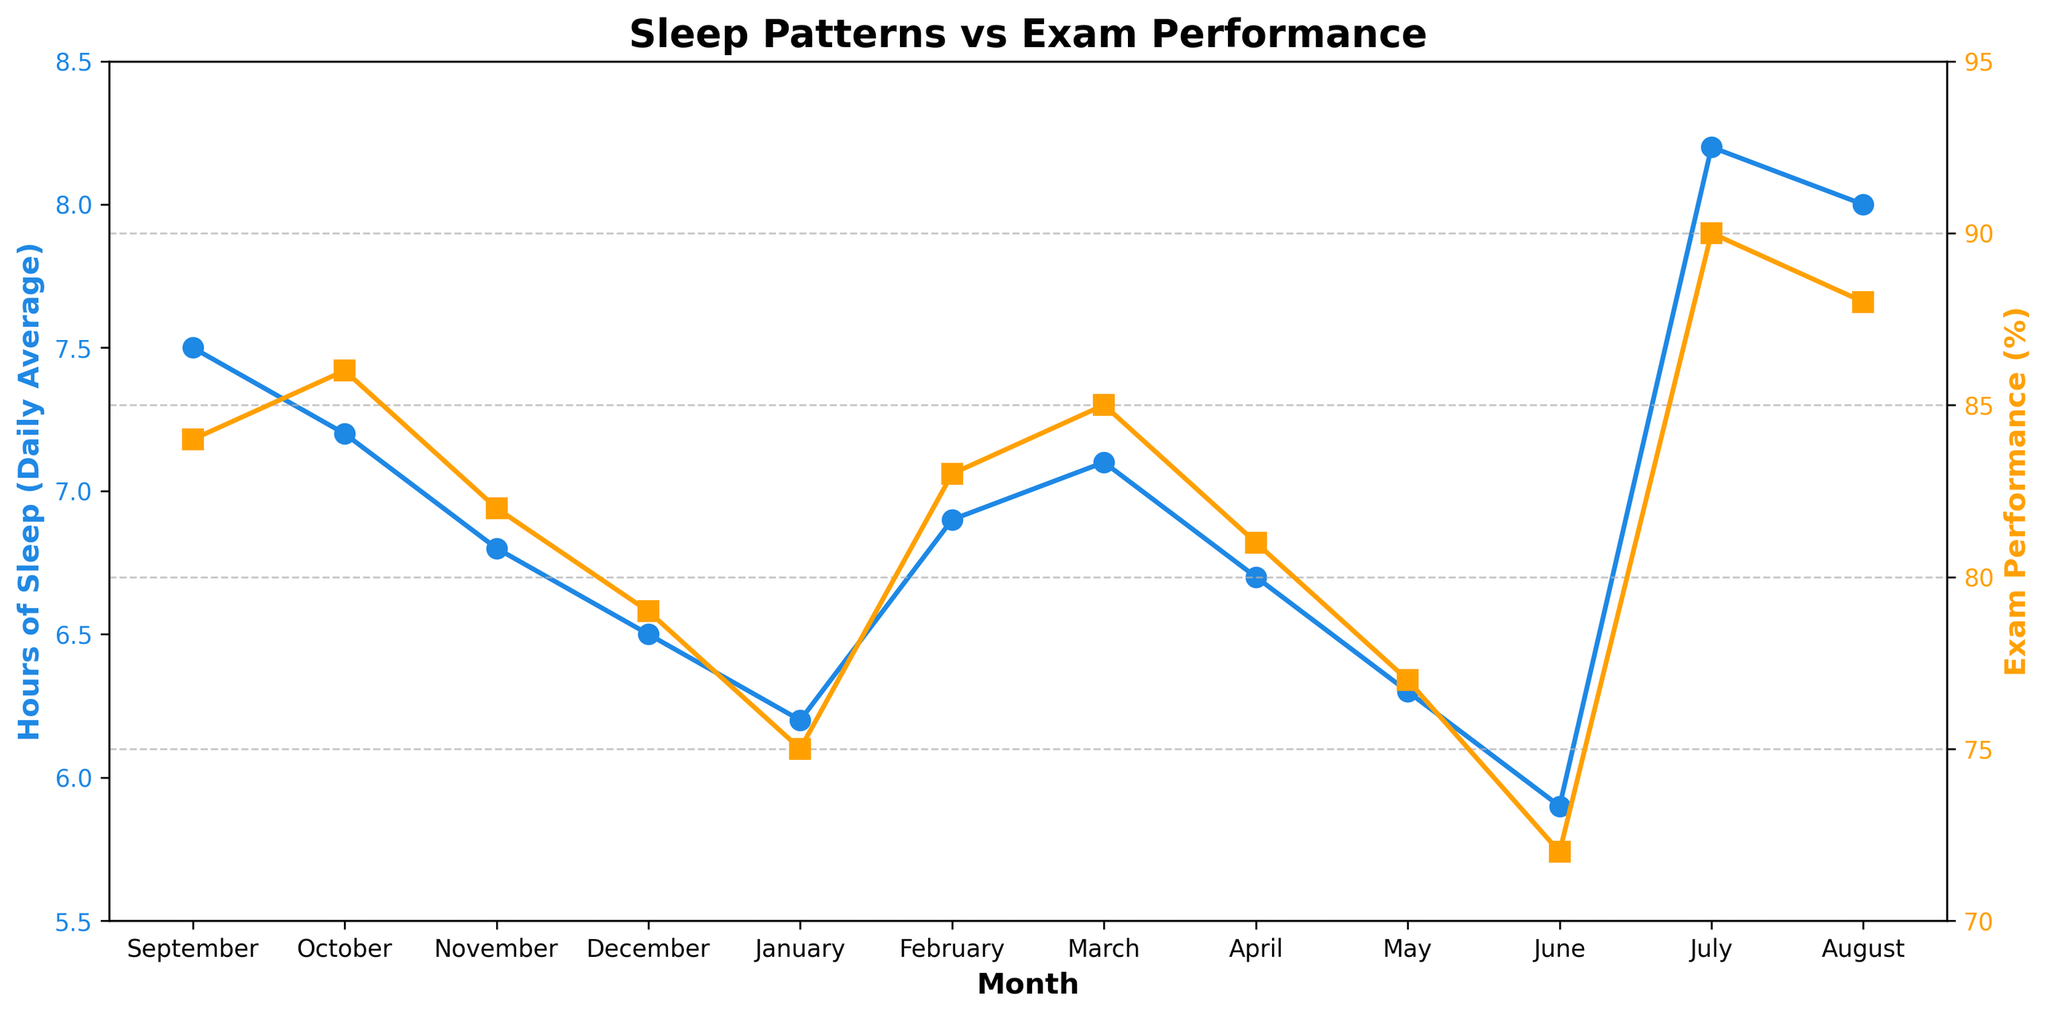What is the relationship between hours of sleep and exam performance in January and June? In January, the average hours of sleep are 6.2, and the exam performance is 75%. In June, the average hours of sleep drop to 5.9, and the exam performance also declines to 72%. This suggests that less sleep is associated with lower exam performance.
Answer: Less sleep, lower performance What are the highest average hours of sleep and their corresponding exam performance? The highest average hours of sleep are in July, at 8.2 hours per day, and the corresponding exam performance is 90%.
Answer: 8.2 hours, 90% During which month does the exam performance see the largest increase, and by how much? From January to February, exam performance increases from 75% to 83%. The difference is 83 - 75 = 8%. This is the largest increase observed.
Answer: February, 8% Compare the exam performance in April and May. Which is higher, and by how much? In April, the exam performance is 81%, and in May, it is 77%. The difference is 81 - 77 = 4%. April has a higher exam performance than May by 4%.
Answer: April, 4% Identify the month with the lowest average hours of sleep and state its exam performance. The lowest average hours of sleep occur in June, at 5.9 hours per day. The exam performance for June is 72%.
Answer: June, 72% How does the exam performance change from September to December? In September, the exam performance is 84%, and it decreases to 79% by December. The change is 84 - 79 = 5%.
Answer: Decreases by 5% What is the difference between the highest and lowest exam performances observed throughout the year? The highest exam performance is in July, at 90%, and the lowest is in June, at 72%. The difference is 90 - 72 = 18%.
Answer: 18% What is the average exam performance for the months when students sleep less than 7 hours? The months with less than 7 hours of sleep are November (82%), December (79%), January (75%), April (81%), May (77%), and June (72%). The average exam performance is (82 + 79 + 75 + 81 + 77 + 72) / 6 = 77.67%.
Answer: 77.67% What trend can you observe about hours of sleep and exam performance from September to January? Both the hours of sleep and exam performance show a decreasing trend from September (7.5 hours, 84%) to January (6.2 hours, 75%).
Answer: Decreasing trend During which months do the average hours of sleep exceed 8 hours, and what is the exam performance for those months? The months with average hours of sleep exceeding 8 hours are July (8.2 hours, 90%) and August (8.0 hours, 88%). The exam performance in July is 90% and in August is 88%.
Answer: July and August, 90% and 88% 